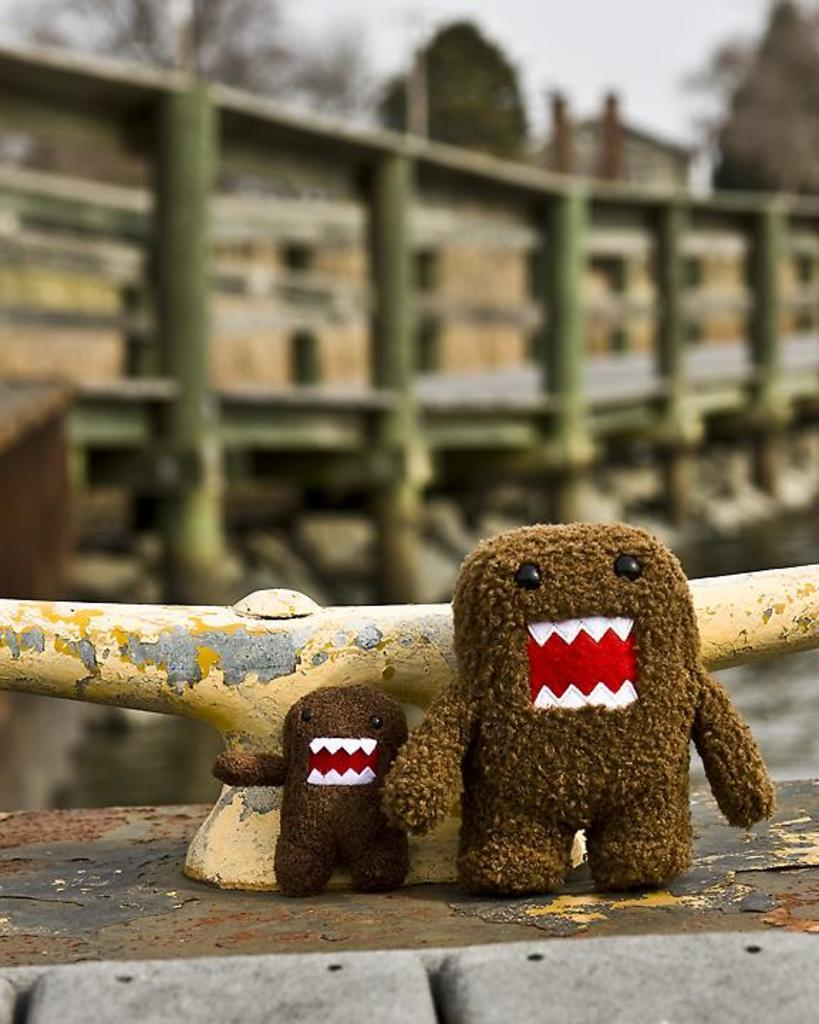What type of objects can be seen in the image? There are two toys in brown color in the image. What can be seen in the background of the image? There is a pole and buildings in the background of the image. What is the color of the sky in the image? The sky is white in color. What is the plot of the story being told in the image? There is no story being told in the image, as it is a static representation of toys, a pole, buildings, and the sky. 